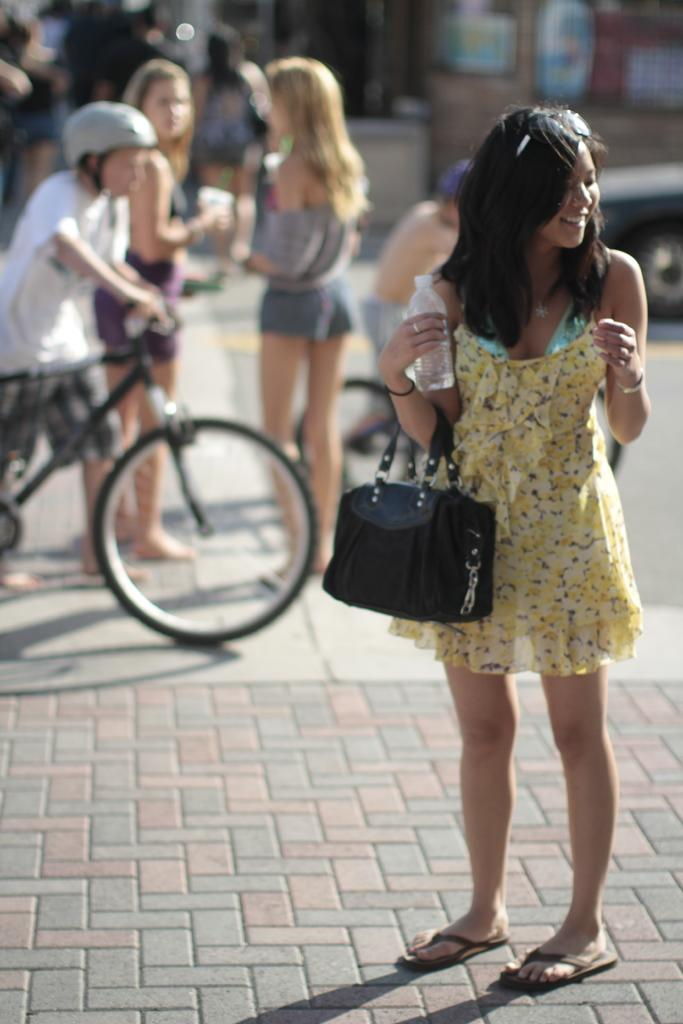Who is present in the image? There is a woman in the image. What is the woman doing in the image? The woman is standing on a footpath. What is the woman holding in the image? The woman is holding a bag and a bottle. What is happening behind the woman in the image? There are people crossing the road behind the woman. What type of flowers can be seen growing on the fog in the image? There is no fog or flowers present in the image. How many chickens are crossing the road behind the woman in the image? There are no chickens present in the image; it is people crossing the road. 